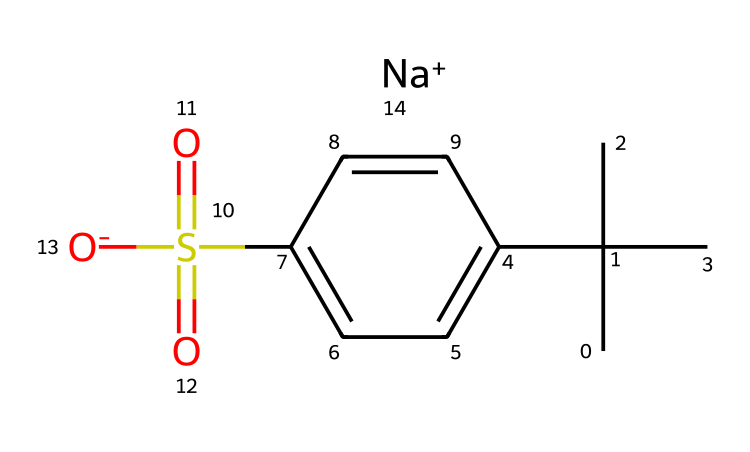What is the main functional group in this chemical structure? The main functional group in this structure is the sulfonate group, identified by the -S(=O)(=O)[O-] part of the SMILES. It indicates the presence of a sulfur atom connected to two oxygen atoms through double bonds and another oxygen with a negative charge.
Answer: sulfonate How many carbon atoms are present in this molecule? By analyzing the SMILES, we can count the carbon atoms within the alkyl (CC(C)(C)) part and the aromatic ring (c1ccc(cc1)). There are a total of 10 carbon atoms.
Answer: 10 What is the type of surfactant represented by this chemical? This chemical is classified as an anionic surfactant due to the presence of a negatively charged sulfonate group, which contributes to its ability to reduce surface tension and emulsify oils.
Answer: anionic What element is the central atom in the sulfonate group? The sulfonate group contains a sulfur atom as its central atom, which establishes the characteristics of the sulfonate functional group in this molecule.
Answer: sulfur What does the 'Na+' signify in this chemical composition? The 'Na+' signifies that this compound is in its sodium salt form, indicating that it has been neutralized and enhances its solubility in water, which is an important property for surfactants in detergents.
Answer: sodium Which part of the molecule is responsible for its hydrophobic nature? The long alkyl chain (CC(C)(C)) is responsible for the hydrophobic nature of this molecule, as it contains hydrophobic carbon and hydrogen atoms that repel water, contributing to the surfactant's functionality.
Answer: alkyl chain 